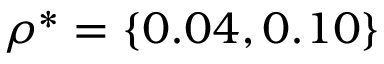Convert formula to latex. <formula><loc_0><loc_0><loc_500><loc_500>\rho ^ { * } = \{ 0 . 0 4 , 0 . 1 0 \}</formula> 